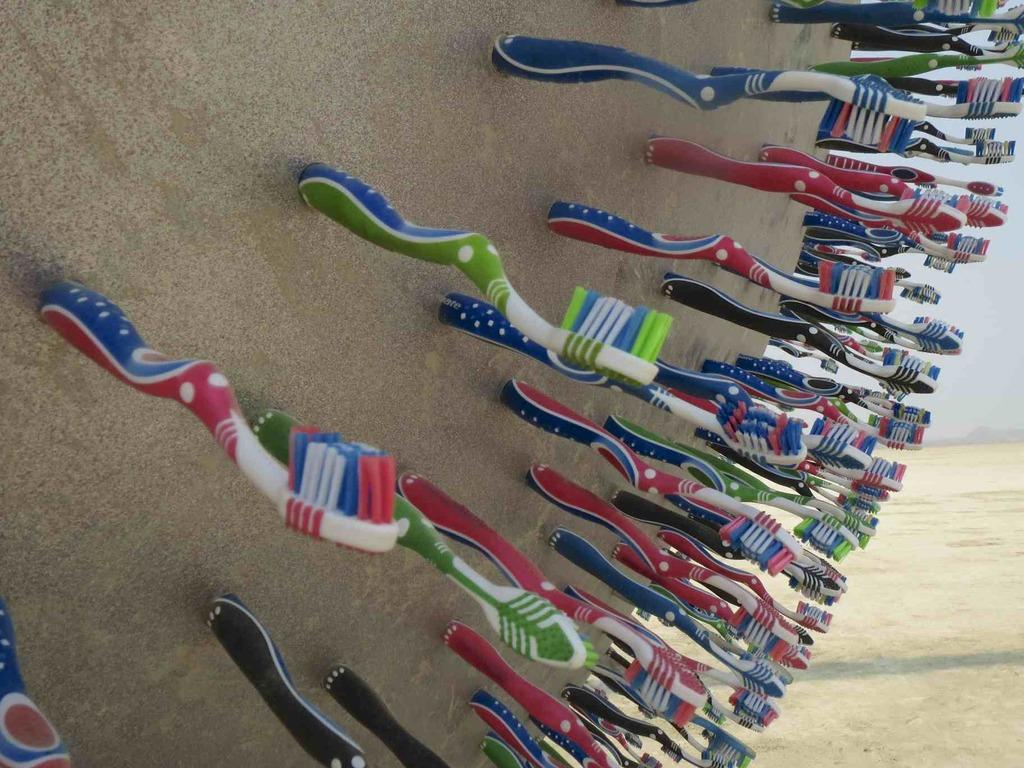What objects are placed on the surface in the image? There are toothbrushes placed on the surface in the image. What color is the wall behind the surface? The wall behind the surface is cream in color. Are there any variations in the wall color? Yes, some parts of the wall are white in color. How many people are sleeping on the surface in the image? There are no people sleeping on the surface in the image; it only shows toothbrushes placed on it. 